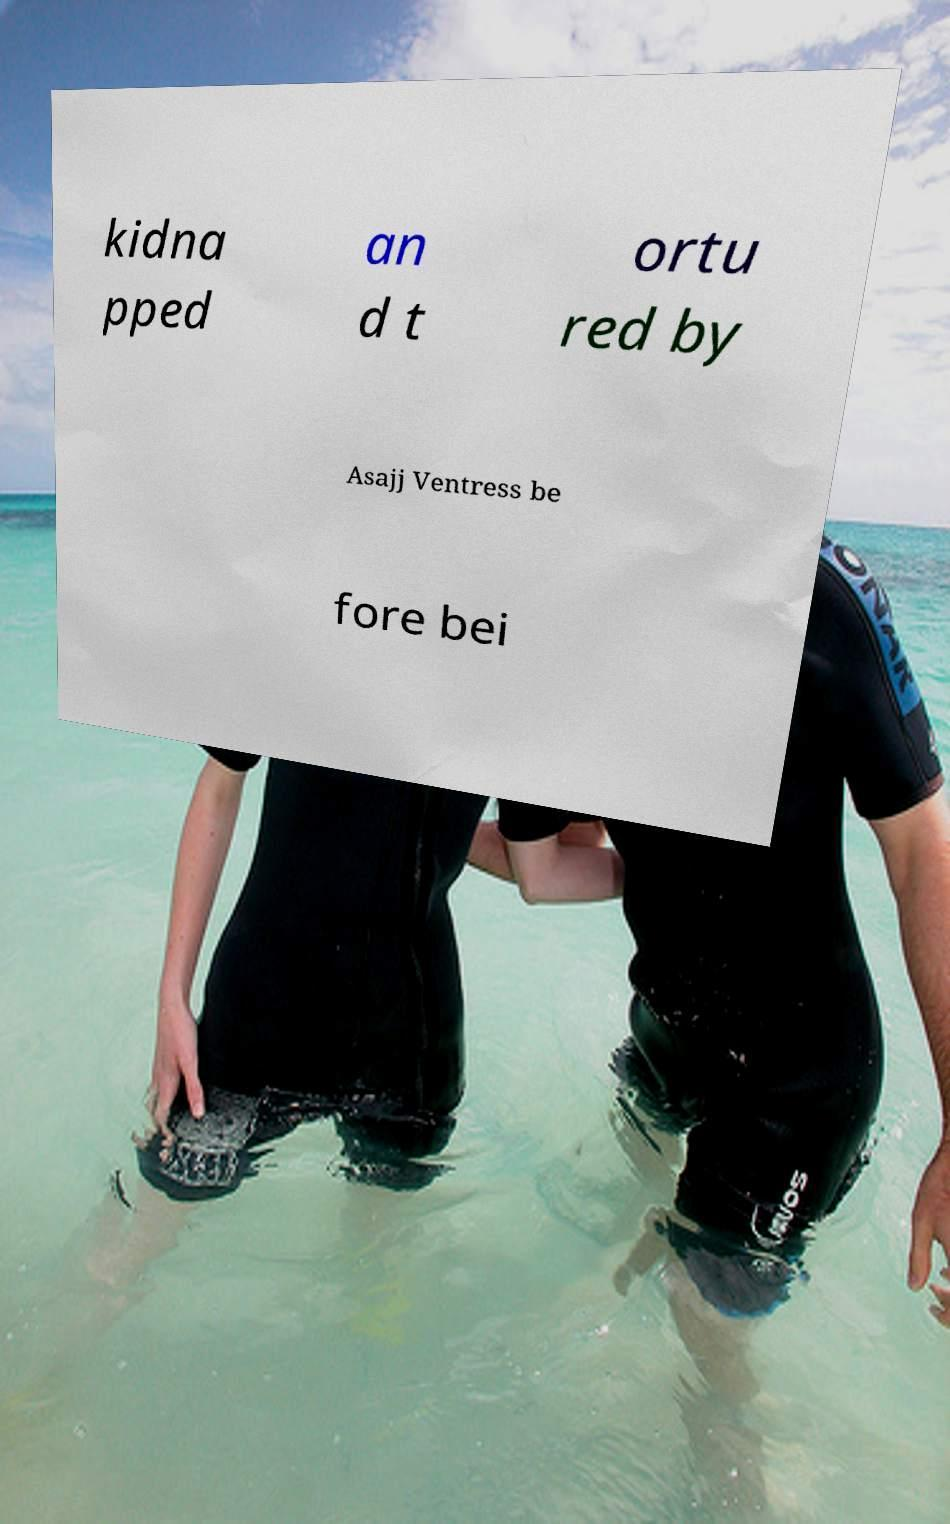Please read and relay the text visible in this image. What does it say? kidna pped an d t ortu red by Asajj Ventress be fore bei 